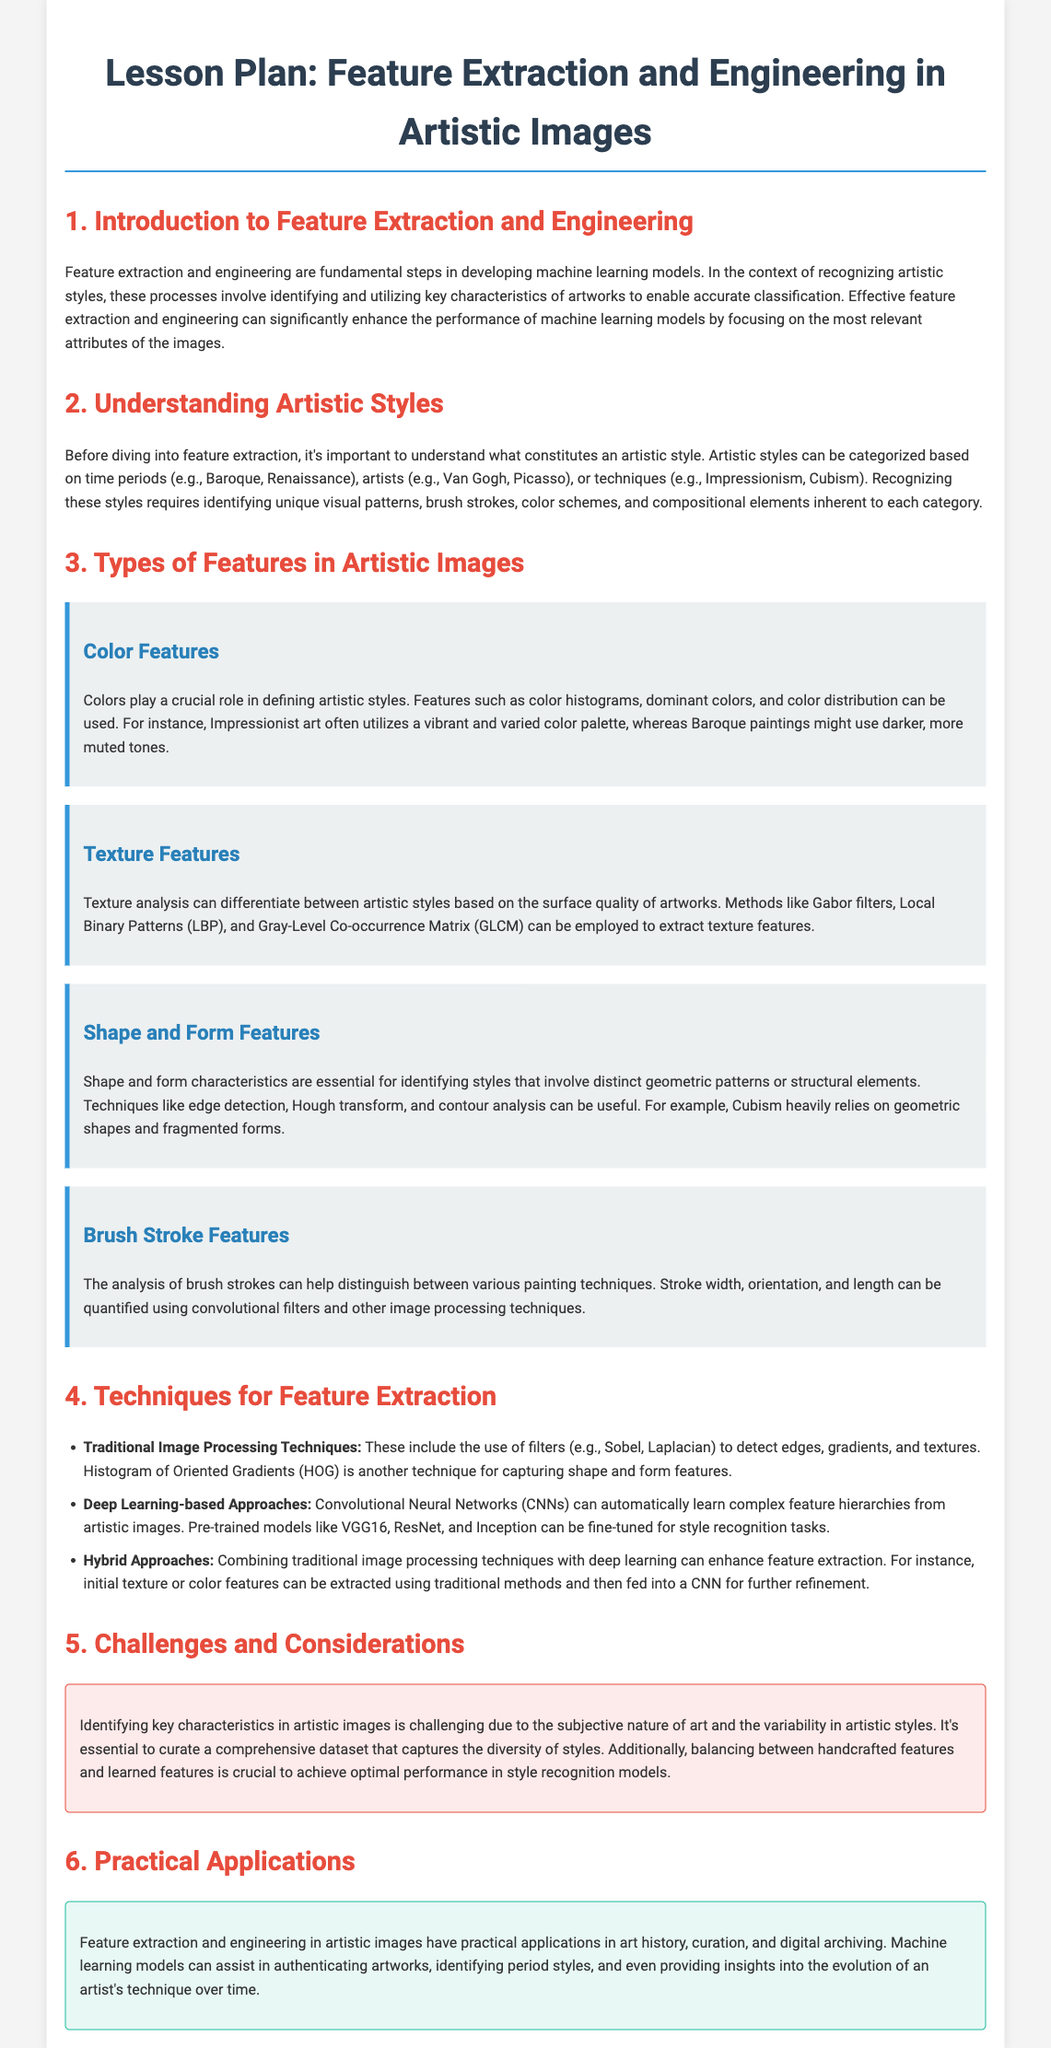What are the two main processes in developing machine learning models? The document mentions that feature extraction and engineering are fundamental steps in developing machine learning models.
Answer: Feature extraction and engineering What types of artistic styles are recognized in the document? The document states that artistic styles can be categorized based on time periods, artists, or techniques.
Answer: Time periods, artists, techniques Which feature extraction method focuses on surface quality? The feature description mentions texture analysis for differentiating styles based on surface quality.
Answer: Texture analysis What traditional technique is used to detect edges in images? The document lists filters like Sobel and Laplacian for edge detection as traditional techniques in feature extraction.
Answer: Sobel What are the practical applications of feature extraction in artistic images? The document outlines applications such as art history, curation, and digital archiving for feature extraction in artistic images.
Answer: Art history, curation, digital archiving Name an example of a deep learning-based approach mentioned. The document lists Convolutional Neural Networks (CNNs) as a deep learning-based approach for feature extraction.
Answer: Convolutional Neural Networks What is a challenge in identifying key characteristics of artistic images? The document describes the subjective nature of art and the variability in artistic styles as challenges in identifying key characteristics.
Answer: Subjective nature of art How can a hybrid approach enhance feature extraction? The document explains that combining traditional image processing techniques with deep learning can enhance feature extraction, as initial features can be refined further.
Answer: Combining traditional methods with deep learning 